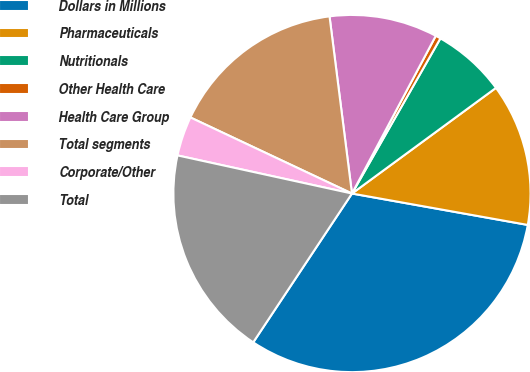Convert chart to OTSL. <chart><loc_0><loc_0><loc_500><loc_500><pie_chart><fcel>Dollars in Millions<fcel>Pharmaceuticals<fcel>Nutritionals<fcel>Other Health Care<fcel>Health Care Group<fcel>Total segments<fcel>Corporate/Other<fcel>Total<nl><fcel>31.51%<fcel>12.89%<fcel>6.68%<fcel>0.47%<fcel>9.78%<fcel>15.99%<fcel>3.58%<fcel>19.1%<nl></chart> 